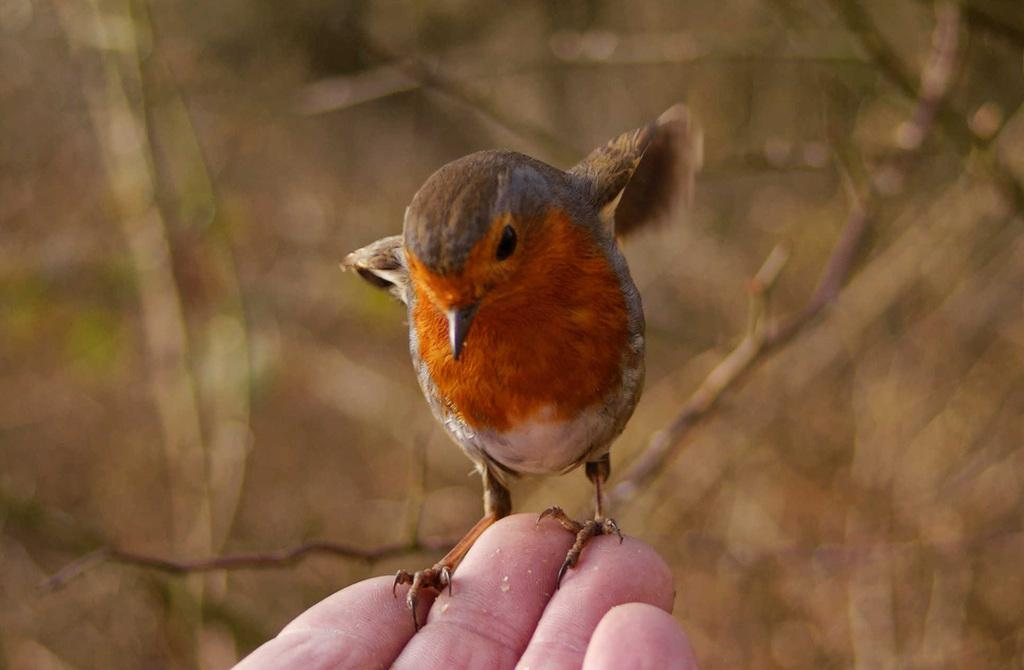What type of animal is in the image? There is a bird in the image. Can you describe the bird's colors? The bird has brown, cream, black, and grey colors. Where is the bird located in the image? The bird is on a human hand. What can be seen in the background of the image? The background of the image is brown and blurry. What type of cracker is the bird eating in the image? There is no cracker present in the image; the bird is on a human hand. How many days are represented in the image? The image does not represent any specific number of days or a week. 